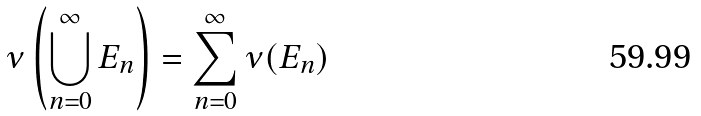Convert formula to latex. <formula><loc_0><loc_0><loc_500><loc_500>\nu \left ( \bigcup _ { n = 0 } ^ { \infty } E _ { n } \right ) = \sum _ { n = 0 } ^ { \infty } \nu ( E _ { n } )</formula> 